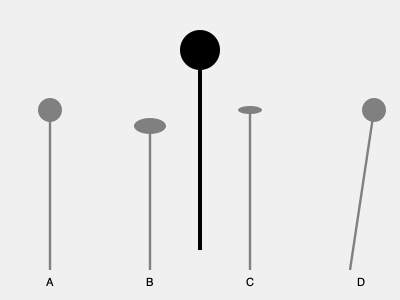Which shadow correctly represents Elvis's iconic microphone stand when the light source is directly above? To determine the correct shadow of Elvis's iconic microphone stand, we need to consider the following steps:

1. Light source position: The question states that the light source is directly above the microphone stand.

2. Stand shape: The original microphone stand is shown as a straight vertical line with a circular top.

3. Shadow properties:
   a. Length: The shadow should be the same length as the stand since the light is directly above.
   b. Shape: The stand's straight part will cast a straight shadow.
   c. Top shape: The circular top will cast an elliptical shadow due to the angle of the light.

4. Analyzing the options:
   A: Correct length, but the top is circular instead of elliptical.
   B: Slightly shorter length, and the top is too wide.
   C: Correct length and the top is correctly elliptical.
   D: Angled shadow, which is incorrect for a light source directly above.

5. Conclusion: Option C is the only shadow that correctly represents the microphone stand with a light source directly above.
Answer: C 